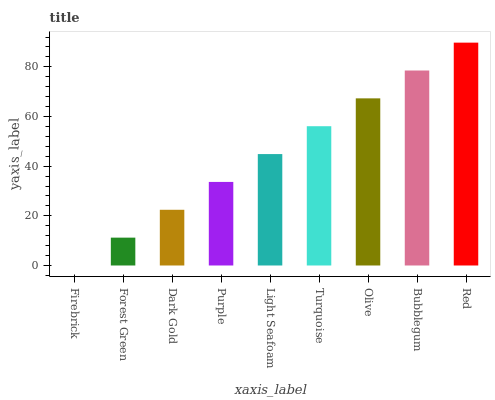Is Forest Green the minimum?
Answer yes or no. No. Is Forest Green the maximum?
Answer yes or no. No. Is Forest Green greater than Firebrick?
Answer yes or no. Yes. Is Firebrick less than Forest Green?
Answer yes or no. Yes. Is Firebrick greater than Forest Green?
Answer yes or no. No. Is Forest Green less than Firebrick?
Answer yes or no. No. Is Light Seafoam the high median?
Answer yes or no. Yes. Is Light Seafoam the low median?
Answer yes or no. Yes. Is Olive the high median?
Answer yes or no. No. Is Bubblegum the low median?
Answer yes or no. No. 